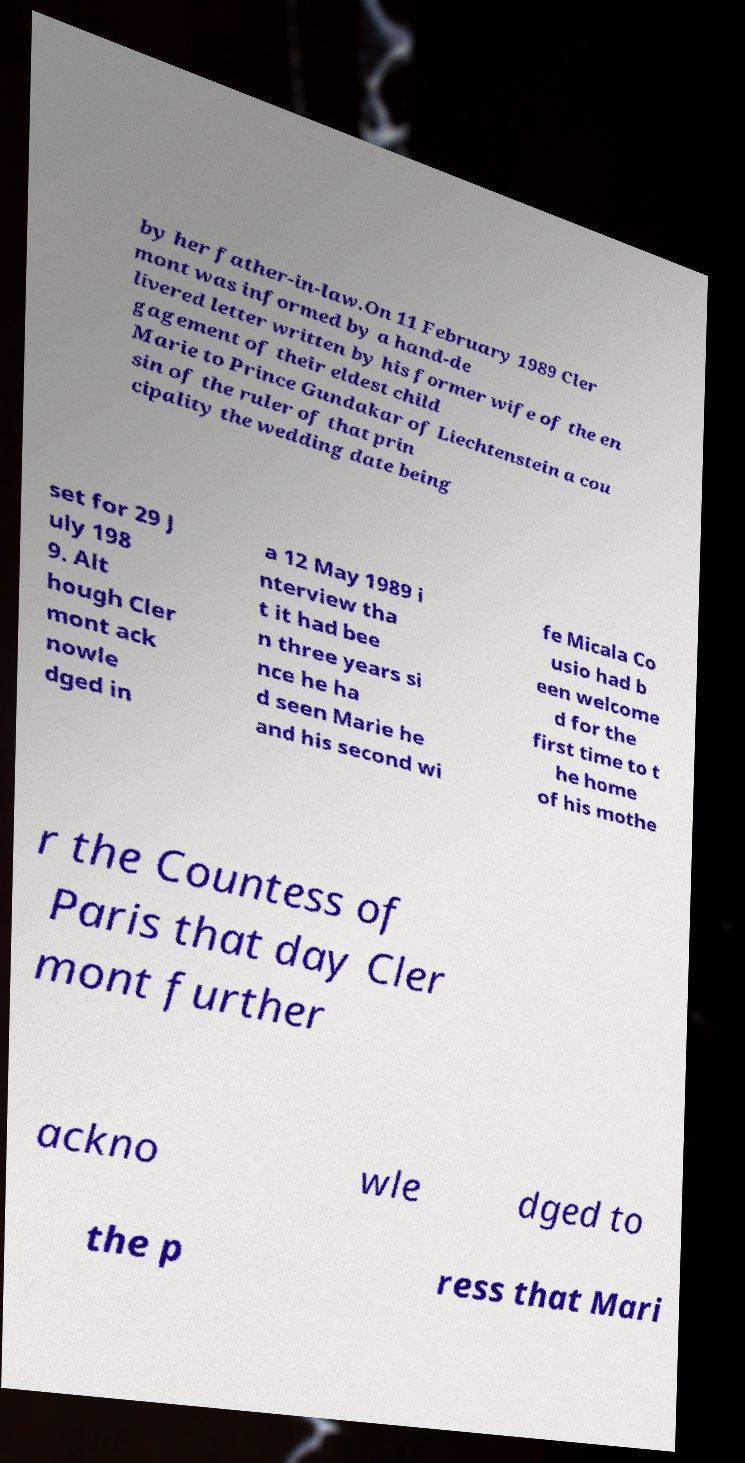Please read and relay the text visible in this image. What does it say? by her father-in-law.On 11 February 1989 Cler mont was informed by a hand-de livered letter written by his former wife of the en gagement of their eldest child Marie to Prince Gundakar of Liechtenstein a cou sin of the ruler of that prin cipality the wedding date being set for 29 J uly 198 9. Alt hough Cler mont ack nowle dged in a 12 May 1989 i nterview tha t it had bee n three years si nce he ha d seen Marie he and his second wi fe Micala Co usio had b een welcome d for the first time to t he home of his mothe r the Countess of Paris that day Cler mont further ackno wle dged to the p ress that Mari 